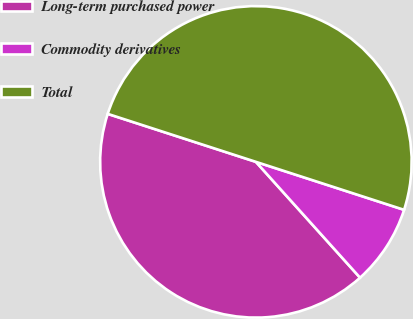<chart> <loc_0><loc_0><loc_500><loc_500><pie_chart><fcel>Long-term purchased power<fcel>Commodity derivatives<fcel>Total<nl><fcel>41.64%<fcel>8.36%<fcel>50.0%<nl></chart> 